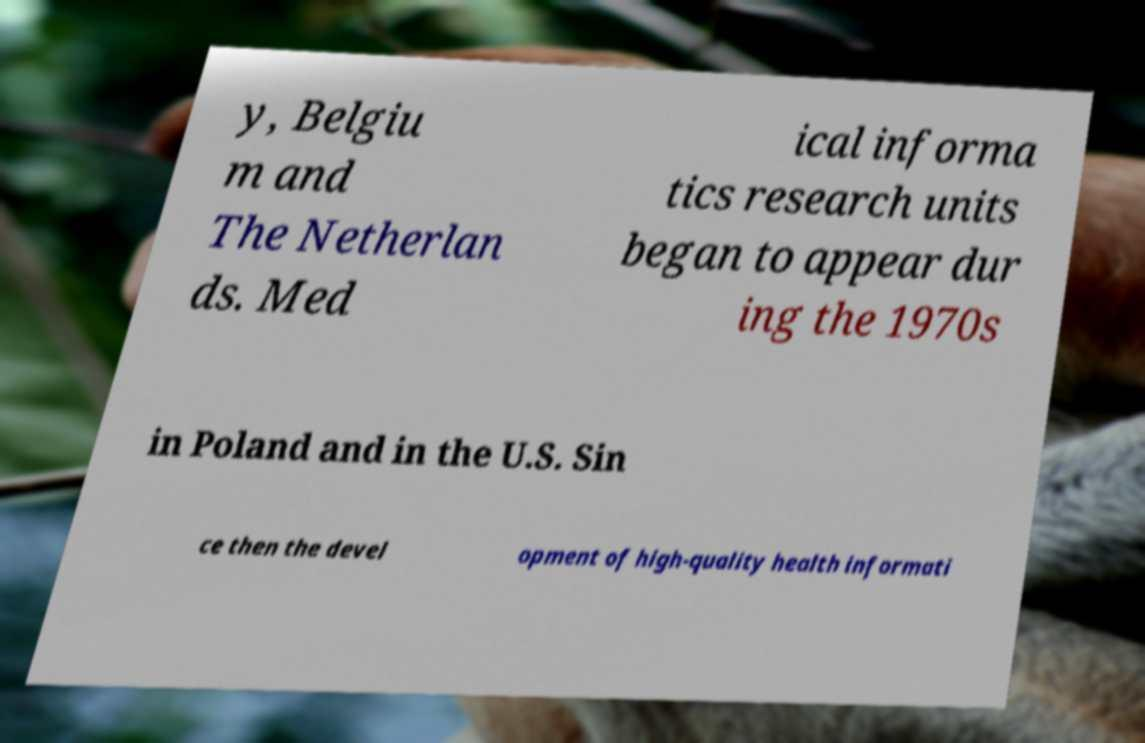Can you accurately transcribe the text from the provided image for me? y, Belgiu m and The Netherlan ds. Med ical informa tics research units began to appear dur ing the 1970s in Poland and in the U.S. Sin ce then the devel opment of high-quality health informati 